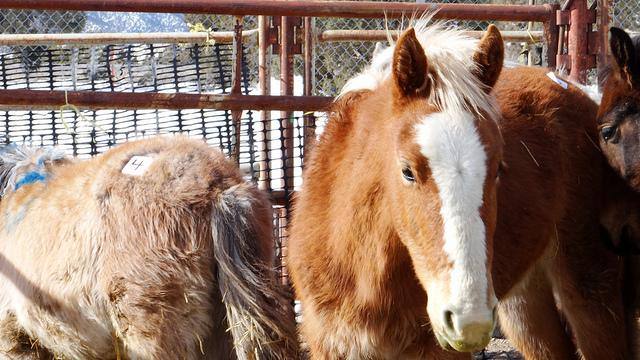What kind of races does this animal run? Please explain your reasoning. derby. The other options don't apply to horse racing. 